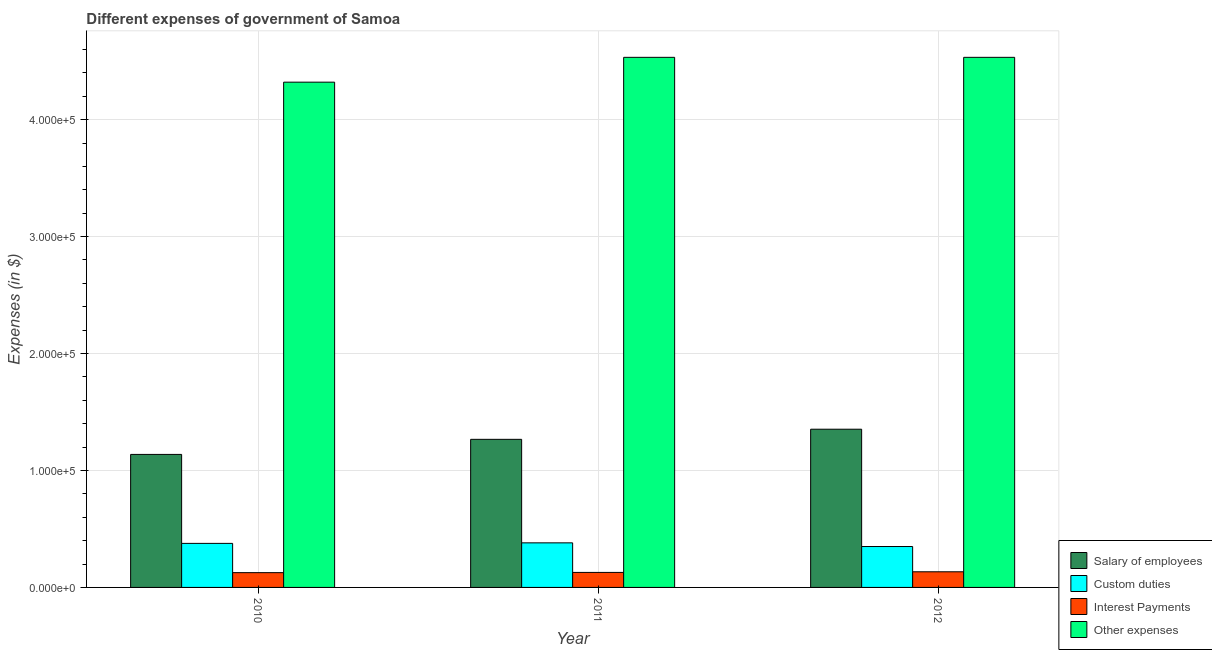How many groups of bars are there?
Ensure brevity in your answer.  3. Are the number of bars per tick equal to the number of legend labels?
Keep it short and to the point. Yes. How many bars are there on the 2nd tick from the right?
Provide a short and direct response. 4. What is the amount spent on other expenses in 2011?
Provide a short and direct response. 4.53e+05. Across all years, what is the maximum amount spent on salary of employees?
Provide a short and direct response. 1.35e+05. Across all years, what is the minimum amount spent on custom duties?
Give a very brief answer. 3.50e+04. In which year was the amount spent on interest payments maximum?
Offer a terse response. 2012. What is the total amount spent on other expenses in the graph?
Your response must be concise. 1.34e+06. What is the difference between the amount spent on other expenses in 2010 and that in 2011?
Your answer should be compact. -2.12e+04. What is the difference between the amount spent on salary of employees in 2010 and the amount spent on custom duties in 2011?
Offer a very short reply. -1.29e+04. What is the average amount spent on custom duties per year?
Provide a succinct answer. 3.69e+04. In the year 2011, what is the difference between the amount spent on interest payments and amount spent on salary of employees?
Make the answer very short. 0. In how many years, is the amount spent on salary of employees greater than 280000 $?
Your answer should be very brief. 0. What is the ratio of the amount spent on interest payments in 2010 to that in 2012?
Your response must be concise. 0.95. What is the difference between the highest and the second highest amount spent on salary of employees?
Offer a very short reply. 8666.97. What is the difference between the highest and the lowest amount spent on interest payments?
Your answer should be very brief. 732.78. Is it the case that in every year, the sum of the amount spent on other expenses and amount spent on interest payments is greater than the sum of amount spent on custom duties and amount spent on salary of employees?
Offer a very short reply. Yes. What does the 4th bar from the left in 2012 represents?
Provide a succinct answer. Other expenses. What does the 4th bar from the right in 2010 represents?
Keep it short and to the point. Salary of employees. How many bars are there?
Ensure brevity in your answer.  12. How many years are there in the graph?
Your answer should be compact. 3. What is the difference between two consecutive major ticks on the Y-axis?
Your answer should be compact. 1.00e+05. Are the values on the major ticks of Y-axis written in scientific E-notation?
Give a very brief answer. Yes. Does the graph contain any zero values?
Provide a short and direct response. No. Where does the legend appear in the graph?
Provide a short and direct response. Bottom right. How many legend labels are there?
Keep it short and to the point. 4. What is the title of the graph?
Give a very brief answer. Different expenses of government of Samoa. What is the label or title of the Y-axis?
Keep it short and to the point. Expenses (in $). What is the Expenses (in $) of Salary of employees in 2010?
Your answer should be very brief. 1.14e+05. What is the Expenses (in $) in Custom duties in 2010?
Your answer should be compact. 3.77e+04. What is the Expenses (in $) in Interest Payments in 2010?
Provide a short and direct response. 1.26e+04. What is the Expenses (in $) of Other expenses in 2010?
Give a very brief answer. 4.32e+05. What is the Expenses (in $) of Salary of employees in 2011?
Provide a short and direct response. 1.27e+05. What is the Expenses (in $) of Custom duties in 2011?
Offer a terse response. 3.81e+04. What is the Expenses (in $) in Interest Payments in 2011?
Your answer should be very brief. 1.28e+04. What is the Expenses (in $) in Other expenses in 2011?
Give a very brief answer. 4.53e+05. What is the Expenses (in $) of Salary of employees in 2012?
Your response must be concise. 1.35e+05. What is the Expenses (in $) of Custom duties in 2012?
Your answer should be very brief. 3.50e+04. What is the Expenses (in $) in Interest Payments in 2012?
Keep it short and to the point. 1.34e+04. What is the Expenses (in $) of Other expenses in 2012?
Provide a short and direct response. 4.53e+05. Across all years, what is the maximum Expenses (in $) in Salary of employees?
Keep it short and to the point. 1.35e+05. Across all years, what is the maximum Expenses (in $) in Custom duties?
Provide a short and direct response. 3.81e+04. Across all years, what is the maximum Expenses (in $) in Interest Payments?
Ensure brevity in your answer.  1.34e+04. Across all years, what is the maximum Expenses (in $) of Other expenses?
Offer a terse response. 4.53e+05. Across all years, what is the minimum Expenses (in $) in Salary of employees?
Ensure brevity in your answer.  1.14e+05. Across all years, what is the minimum Expenses (in $) in Custom duties?
Your answer should be very brief. 3.50e+04. Across all years, what is the minimum Expenses (in $) in Interest Payments?
Give a very brief answer. 1.26e+04. Across all years, what is the minimum Expenses (in $) in Other expenses?
Your answer should be very brief. 4.32e+05. What is the total Expenses (in $) in Salary of employees in the graph?
Offer a very short reply. 3.76e+05. What is the total Expenses (in $) of Custom duties in the graph?
Your answer should be compact. 1.11e+05. What is the total Expenses (in $) of Interest Payments in the graph?
Make the answer very short. 3.88e+04. What is the total Expenses (in $) in Other expenses in the graph?
Keep it short and to the point. 1.34e+06. What is the difference between the Expenses (in $) of Salary of employees in 2010 and that in 2011?
Your answer should be compact. -1.29e+04. What is the difference between the Expenses (in $) of Custom duties in 2010 and that in 2011?
Provide a succinct answer. -446.14. What is the difference between the Expenses (in $) in Interest Payments in 2010 and that in 2011?
Provide a succinct answer. -201.28. What is the difference between the Expenses (in $) of Other expenses in 2010 and that in 2011?
Your answer should be compact. -2.12e+04. What is the difference between the Expenses (in $) of Salary of employees in 2010 and that in 2012?
Offer a terse response. -2.16e+04. What is the difference between the Expenses (in $) in Custom duties in 2010 and that in 2012?
Ensure brevity in your answer.  2691.4. What is the difference between the Expenses (in $) of Interest Payments in 2010 and that in 2012?
Your answer should be very brief. -732.78. What is the difference between the Expenses (in $) in Other expenses in 2010 and that in 2012?
Give a very brief answer. -2.12e+04. What is the difference between the Expenses (in $) of Salary of employees in 2011 and that in 2012?
Your response must be concise. -8666.97. What is the difference between the Expenses (in $) of Custom duties in 2011 and that in 2012?
Your response must be concise. 3137.54. What is the difference between the Expenses (in $) of Interest Payments in 2011 and that in 2012?
Offer a very short reply. -531.5. What is the difference between the Expenses (in $) of Other expenses in 2011 and that in 2012?
Provide a succinct answer. -5.38. What is the difference between the Expenses (in $) of Salary of employees in 2010 and the Expenses (in $) of Custom duties in 2011?
Offer a terse response. 7.56e+04. What is the difference between the Expenses (in $) in Salary of employees in 2010 and the Expenses (in $) in Interest Payments in 2011?
Give a very brief answer. 1.01e+05. What is the difference between the Expenses (in $) of Salary of employees in 2010 and the Expenses (in $) of Other expenses in 2011?
Ensure brevity in your answer.  -3.40e+05. What is the difference between the Expenses (in $) in Custom duties in 2010 and the Expenses (in $) in Interest Payments in 2011?
Offer a terse response. 2.48e+04. What is the difference between the Expenses (in $) of Custom duties in 2010 and the Expenses (in $) of Other expenses in 2011?
Keep it short and to the point. -4.16e+05. What is the difference between the Expenses (in $) in Interest Payments in 2010 and the Expenses (in $) in Other expenses in 2011?
Your answer should be compact. -4.41e+05. What is the difference between the Expenses (in $) in Salary of employees in 2010 and the Expenses (in $) in Custom duties in 2012?
Ensure brevity in your answer.  7.88e+04. What is the difference between the Expenses (in $) in Salary of employees in 2010 and the Expenses (in $) in Interest Payments in 2012?
Make the answer very short. 1.00e+05. What is the difference between the Expenses (in $) in Salary of employees in 2010 and the Expenses (in $) in Other expenses in 2012?
Your response must be concise. -3.40e+05. What is the difference between the Expenses (in $) of Custom duties in 2010 and the Expenses (in $) of Interest Payments in 2012?
Keep it short and to the point. 2.43e+04. What is the difference between the Expenses (in $) in Custom duties in 2010 and the Expenses (in $) in Other expenses in 2012?
Ensure brevity in your answer.  -4.16e+05. What is the difference between the Expenses (in $) in Interest Payments in 2010 and the Expenses (in $) in Other expenses in 2012?
Ensure brevity in your answer.  -4.41e+05. What is the difference between the Expenses (in $) in Salary of employees in 2011 and the Expenses (in $) in Custom duties in 2012?
Give a very brief answer. 9.17e+04. What is the difference between the Expenses (in $) in Salary of employees in 2011 and the Expenses (in $) in Interest Payments in 2012?
Your response must be concise. 1.13e+05. What is the difference between the Expenses (in $) in Salary of employees in 2011 and the Expenses (in $) in Other expenses in 2012?
Provide a succinct answer. -3.27e+05. What is the difference between the Expenses (in $) in Custom duties in 2011 and the Expenses (in $) in Interest Payments in 2012?
Keep it short and to the point. 2.47e+04. What is the difference between the Expenses (in $) in Custom duties in 2011 and the Expenses (in $) in Other expenses in 2012?
Your answer should be very brief. -4.15e+05. What is the difference between the Expenses (in $) in Interest Payments in 2011 and the Expenses (in $) in Other expenses in 2012?
Make the answer very short. -4.40e+05. What is the average Expenses (in $) of Salary of employees per year?
Make the answer very short. 1.25e+05. What is the average Expenses (in $) in Custom duties per year?
Offer a terse response. 3.69e+04. What is the average Expenses (in $) of Interest Payments per year?
Offer a terse response. 1.29e+04. What is the average Expenses (in $) of Other expenses per year?
Your answer should be very brief. 4.46e+05. In the year 2010, what is the difference between the Expenses (in $) in Salary of employees and Expenses (in $) in Custom duties?
Your answer should be compact. 7.61e+04. In the year 2010, what is the difference between the Expenses (in $) in Salary of employees and Expenses (in $) in Interest Payments?
Give a very brief answer. 1.01e+05. In the year 2010, what is the difference between the Expenses (in $) of Salary of employees and Expenses (in $) of Other expenses?
Your answer should be compact. -3.18e+05. In the year 2010, what is the difference between the Expenses (in $) in Custom duties and Expenses (in $) in Interest Payments?
Provide a succinct answer. 2.50e+04. In the year 2010, what is the difference between the Expenses (in $) of Custom duties and Expenses (in $) of Other expenses?
Your answer should be very brief. -3.94e+05. In the year 2010, what is the difference between the Expenses (in $) of Interest Payments and Expenses (in $) of Other expenses?
Your response must be concise. -4.19e+05. In the year 2011, what is the difference between the Expenses (in $) of Salary of employees and Expenses (in $) of Custom duties?
Make the answer very short. 8.85e+04. In the year 2011, what is the difference between the Expenses (in $) in Salary of employees and Expenses (in $) in Interest Payments?
Provide a succinct answer. 1.14e+05. In the year 2011, what is the difference between the Expenses (in $) in Salary of employees and Expenses (in $) in Other expenses?
Make the answer very short. -3.27e+05. In the year 2011, what is the difference between the Expenses (in $) in Custom duties and Expenses (in $) in Interest Payments?
Give a very brief answer. 2.53e+04. In the year 2011, what is the difference between the Expenses (in $) in Custom duties and Expenses (in $) in Other expenses?
Your answer should be very brief. -4.15e+05. In the year 2011, what is the difference between the Expenses (in $) of Interest Payments and Expenses (in $) of Other expenses?
Give a very brief answer. -4.40e+05. In the year 2012, what is the difference between the Expenses (in $) in Salary of employees and Expenses (in $) in Custom duties?
Give a very brief answer. 1.00e+05. In the year 2012, what is the difference between the Expenses (in $) of Salary of employees and Expenses (in $) of Interest Payments?
Provide a short and direct response. 1.22e+05. In the year 2012, what is the difference between the Expenses (in $) in Salary of employees and Expenses (in $) in Other expenses?
Offer a terse response. -3.18e+05. In the year 2012, what is the difference between the Expenses (in $) of Custom duties and Expenses (in $) of Interest Payments?
Offer a terse response. 2.16e+04. In the year 2012, what is the difference between the Expenses (in $) of Custom duties and Expenses (in $) of Other expenses?
Your answer should be compact. -4.18e+05. In the year 2012, what is the difference between the Expenses (in $) in Interest Payments and Expenses (in $) in Other expenses?
Keep it short and to the point. -4.40e+05. What is the ratio of the Expenses (in $) of Salary of employees in 2010 to that in 2011?
Give a very brief answer. 0.9. What is the ratio of the Expenses (in $) in Custom duties in 2010 to that in 2011?
Ensure brevity in your answer.  0.99. What is the ratio of the Expenses (in $) of Interest Payments in 2010 to that in 2011?
Offer a very short reply. 0.98. What is the ratio of the Expenses (in $) in Other expenses in 2010 to that in 2011?
Your answer should be very brief. 0.95. What is the ratio of the Expenses (in $) of Salary of employees in 2010 to that in 2012?
Make the answer very short. 0.84. What is the ratio of the Expenses (in $) of Custom duties in 2010 to that in 2012?
Offer a very short reply. 1.08. What is the ratio of the Expenses (in $) in Interest Payments in 2010 to that in 2012?
Keep it short and to the point. 0.95. What is the ratio of the Expenses (in $) of Other expenses in 2010 to that in 2012?
Make the answer very short. 0.95. What is the ratio of the Expenses (in $) in Salary of employees in 2011 to that in 2012?
Ensure brevity in your answer.  0.94. What is the ratio of the Expenses (in $) of Custom duties in 2011 to that in 2012?
Provide a succinct answer. 1.09. What is the ratio of the Expenses (in $) of Interest Payments in 2011 to that in 2012?
Offer a very short reply. 0.96. What is the difference between the highest and the second highest Expenses (in $) of Salary of employees?
Make the answer very short. 8666.97. What is the difference between the highest and the second highest Expenses (in $) in Custom duties?
Keep it short and to the point. 446.14. What is the difference between the highest and the second highest Expenses (in $) in Interest Payments?
Ensure brevity in your answer.  531.5. What is the difference between the highest and the second highest Expenses (in $) in Other expenses?
Provide a short and direct response. 5.38. What is the difference between the highest and the lowest Expenses (in $) of Salary of employees?
Provide a short and direct response. 2.16e+04. What is the difference between the highest and the lowest Expenses (in $) of Custom duties?
Ensure brevity in your answer.  3137.54. What is the difference between the highest and the lowest Expenses (in $) of Interest Payments?
Keep it short and to the point. 732.78. What is the difference between the highest and the lowest Expenses (in $) in Other expenses?
Make the answer very short. 2.12e+04. 